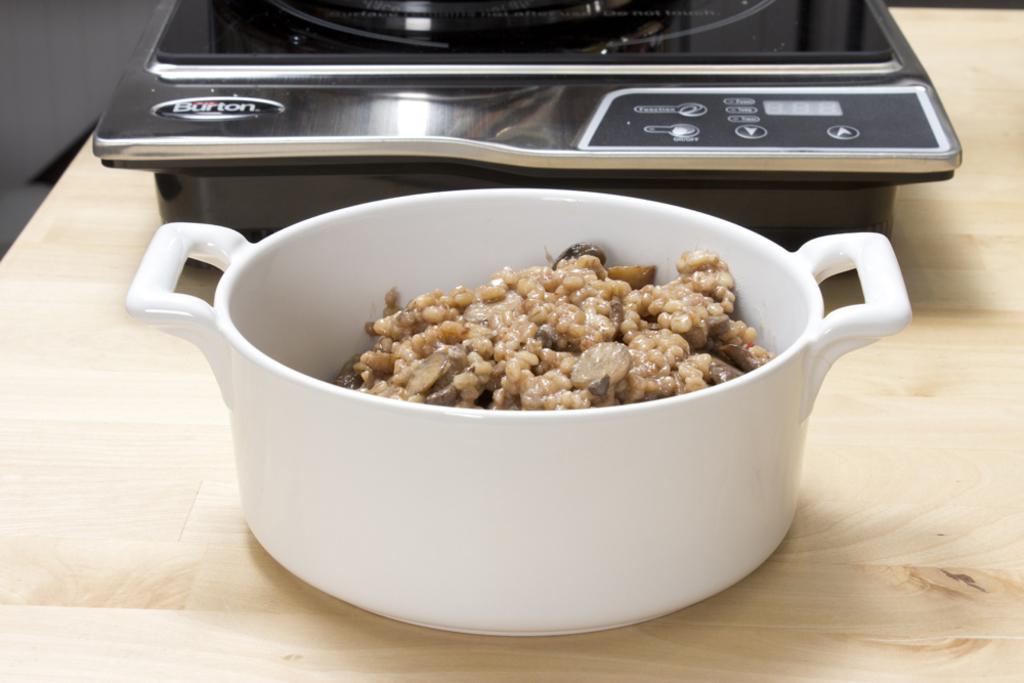Is the object in the back made by barton?
Your answer should be very brief. Yes. 